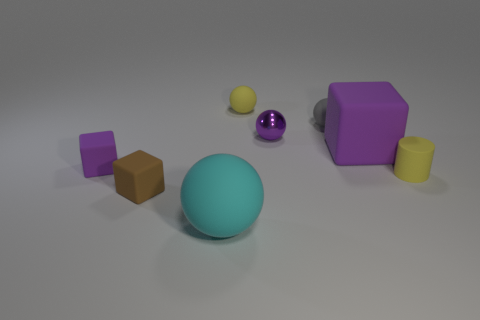Add 1 cylinders. How many objects exist? 9 Subtract all blocks. How many objects are left? 5 Add 6 purple rubber objects. How many purple rubber objects are left? 8 Add 3 small brown blocks. How many small brown blocks exist? 4 Subtract 1 cyan spheres. How many objects are left? 7 Subtract all small brown things. Subtract all tiny gray balls. How many objects are left? 6 